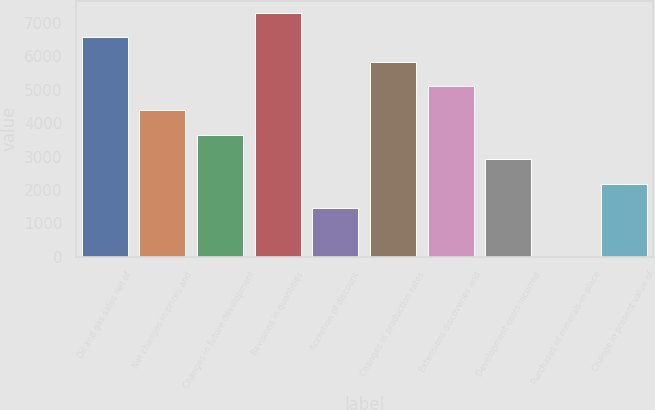Convert chart. <chart><loc_0><loc_0><loc_500><loc_500><bar_chart><fcel>Oil and gas sales net of<fcel>Net changes in prices and<fcel>Changes in future development<fcel>Revisions in quantities<fcel>Accretion of discount<fcel>Changes in production rates<fcel>Extensions discoveries and<fcel>Development costs incurred<fcel>Purchases of minerals-in-place<fcel>Change in present value of<nl><fcel>6571.3<fcel>4382.2<fcel>3652.5<fcel>7301<fcel>1463.4<fcel>5841.6<fcel>5111.9<fcel>2922.8<fcel>4<fcel>2193.1<nl></chart> 